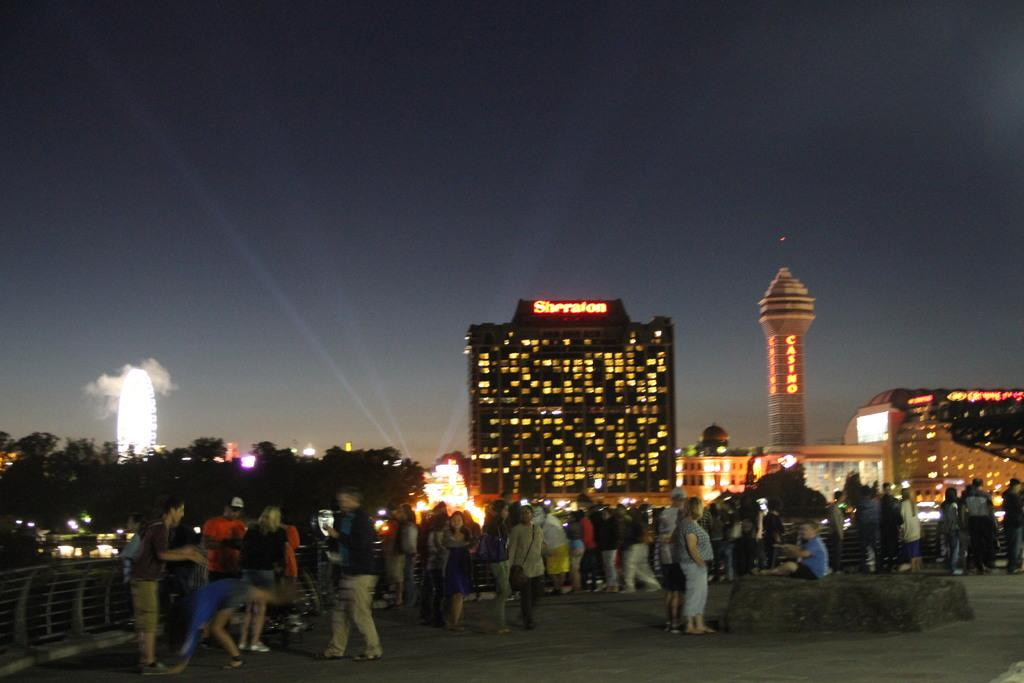What can be seen on the ground in the image? There are people on the ground in the image. What type of structures are present in the image? There are buildings and towers in the image. What other natural elements can be seen in the image? There are trees in the image. What type of illumination is present in the image? There are lights in the image. What type of barrier is present in the image? There is a fence in the image. What can be seen in the background of the image? The sky is visible in the background of the image. What type of distribution system is present in the image? There is no distribution system mentioned or visible in the image. What is the state of the people's minds in the image? There is no information about the people's mental state in the image. 